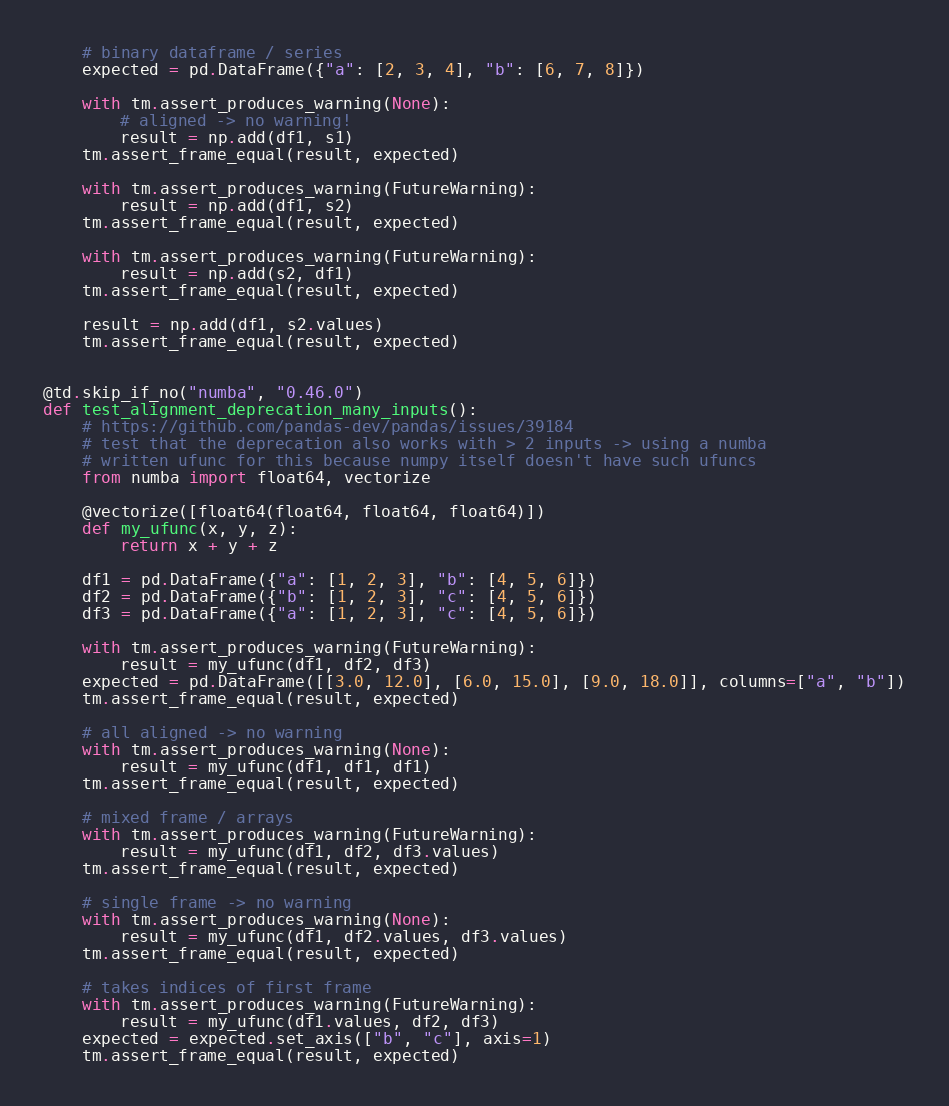Convert code to text. <code><loc_0><loc_0><loc_500><loc_500><_Python_>    # binary dataframe / series
    expected = pd.DataFrame({"a": [2, 3, 4], "b": [6, 7, 8]})

    with tm.assert_produces_warning(None):
        # aligned -> no warning!
        result = np.add(df1, s1)
    tm.assert_frame_equal(result, expected)

    with tm.assert_produces_warning(FutureWarning):
        result = np.add(df1, s2)
    tm.assert_frame_equal(result, expected)

    with tm.assert_produces_warning(FutureWarning):
        result = np.add(s2, df1)
    tm.assert_frame_equal(result, expected)

    result = np.add(df1, s2.values)
    tm.assert_frame_equal(result, expected)


@td.skip_if_no("numba", "0.46.0")
def test_alignment_deprecation_many_inputs():
    # https://github.com/pandas-dev/pandas/issues/39184
    # test that the deprecation also works with > 2 inputs -> using a numba
    # written ufunc for this because numpy itself doesn't have such ufuncs
    from numba import float64, vectorize

    @vectorize([float64(float64, float64, float64)])
    def my_ufunc(x, y, z):
        return x + y + z

    df1 = pd.DataFrame({"a": [1, 2, 3], "b": [4, 5, 6]})
    df2 = pd.DataFrame({"b": [1, 2, 3], "c": [4, 5, 6]})
    df3 = pd.DataFrame({"a": [1, 2, 3], "c": [4, 5, 6]})

    with tm.assert_produces_warning(FutureWarning):
        result = my_ufunc(df1, df2, df3)
    expected = pd.DataFrame([[3.0, 12.0], [6.0, 15.0], [9.0, 18.0]], columns=["a", "b"])
    tm.assert_frame_equal(result, expected)

    # all aligned -> no warning
    with tm.assert_produces_warning(None):
        result = my_ufunc(df1, df1, df1)
    tm.assert_frame_equal(result, expected)

    # mixed frame / arrays
    with tm.assert_produces_warning(FutureWarning):
        result = my_ufunc(df1, df2, df3.values)
    tm.assert_frame_equal(result, expected)

    # single frame -> no warning
    with tm.assert_produces_warning(None):
        result = my_ufunc(df1, df2.values, df3.values)
    tm.assert_frame_equal(result, expected)

    # takes indices of first frame
    with tm.assert_produces_warning(FutureWarning):
        result = my_ufunc(df1.values, df2, df3)
    expected = expected.set_axis(["b", "c"], axis=1)
    tm.assert_frame_equal(result, expected)
</code> 